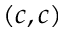Convert formula to latex. <formula><loc_0><loc_0><loc_500><loc_500>( c , c )</formula> 